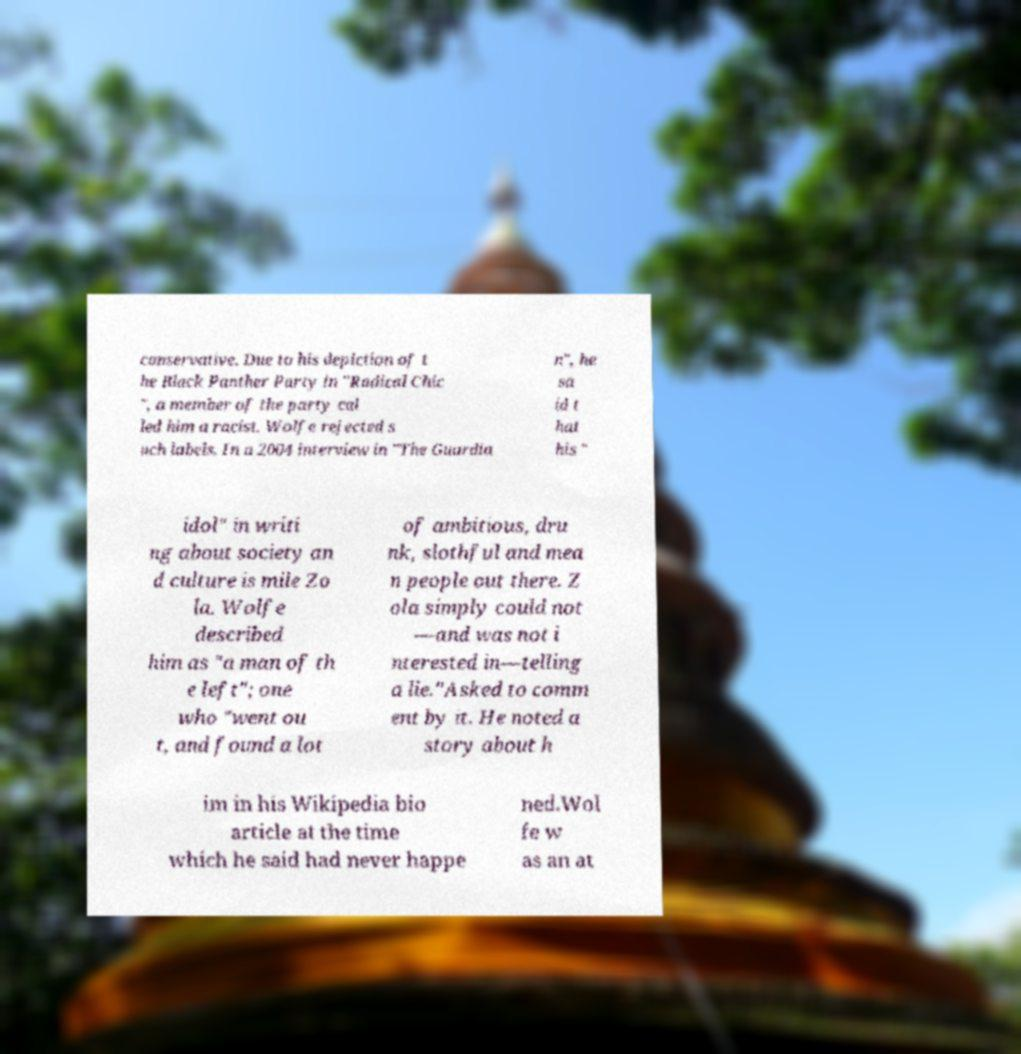Can you accurately transcribe the text from the provided image for me? conservative. Due to his depiction of t he Black Panther Party in "Radical Chic ", a member of the party cal led him a racist. Wolfe rejected s uch labels. In a 2004 interview in "The Guardia n", he sa id t hat his " idol" in writi ng about society an d culture is mile Zo la. Wolfe described him as "a man of th e left"; one who "went ou t, and found a lot of ambitious, dru nk, slothful and mea n people out there. Z ola simply could not —and was not i nterested in—telling a lie."Asked to comm ent by it. He noted a story about h im in his Wikipedia bio article at the time which he said had never happe ned.Wol fe w as an at 